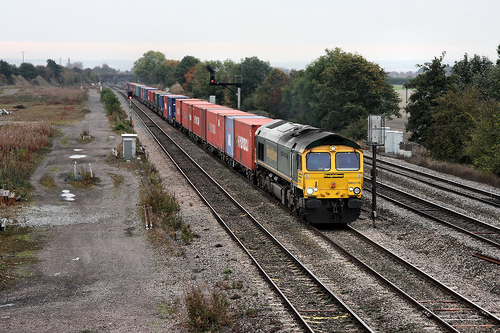<image>
Is there a pole under the train? No. The pole is not positioned under the train. The vertical relationship between these objects is different. 